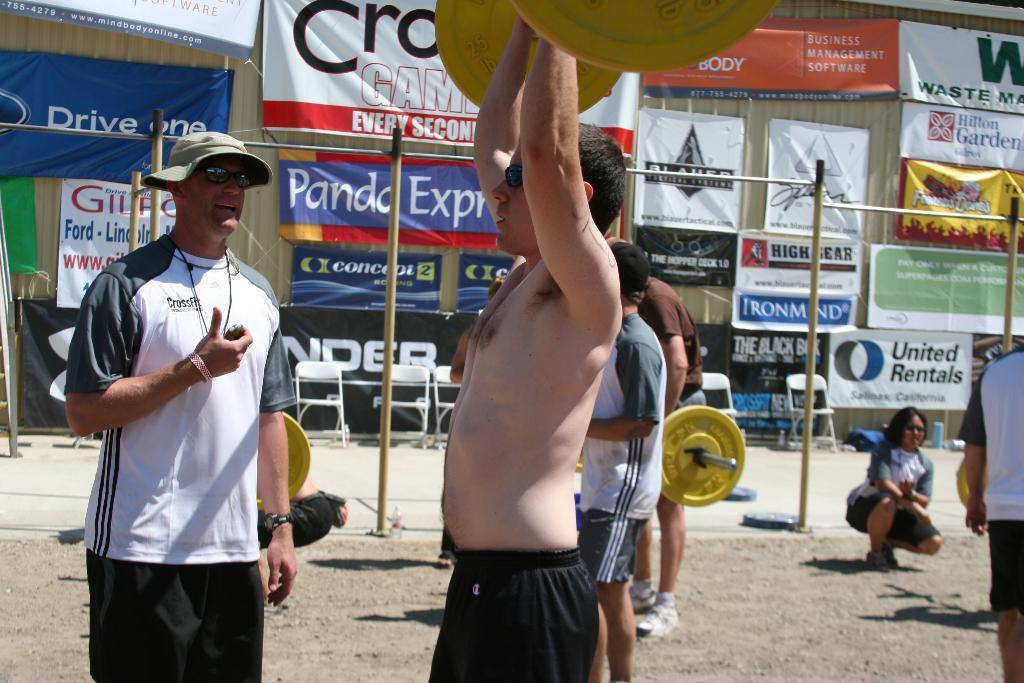Could you give a brief overview of what you see in this image? In this image we can see a few people are holding heavy weights along with a trainer, behind them, we can also see few poles, chairs and a few banners hanging on the building. 